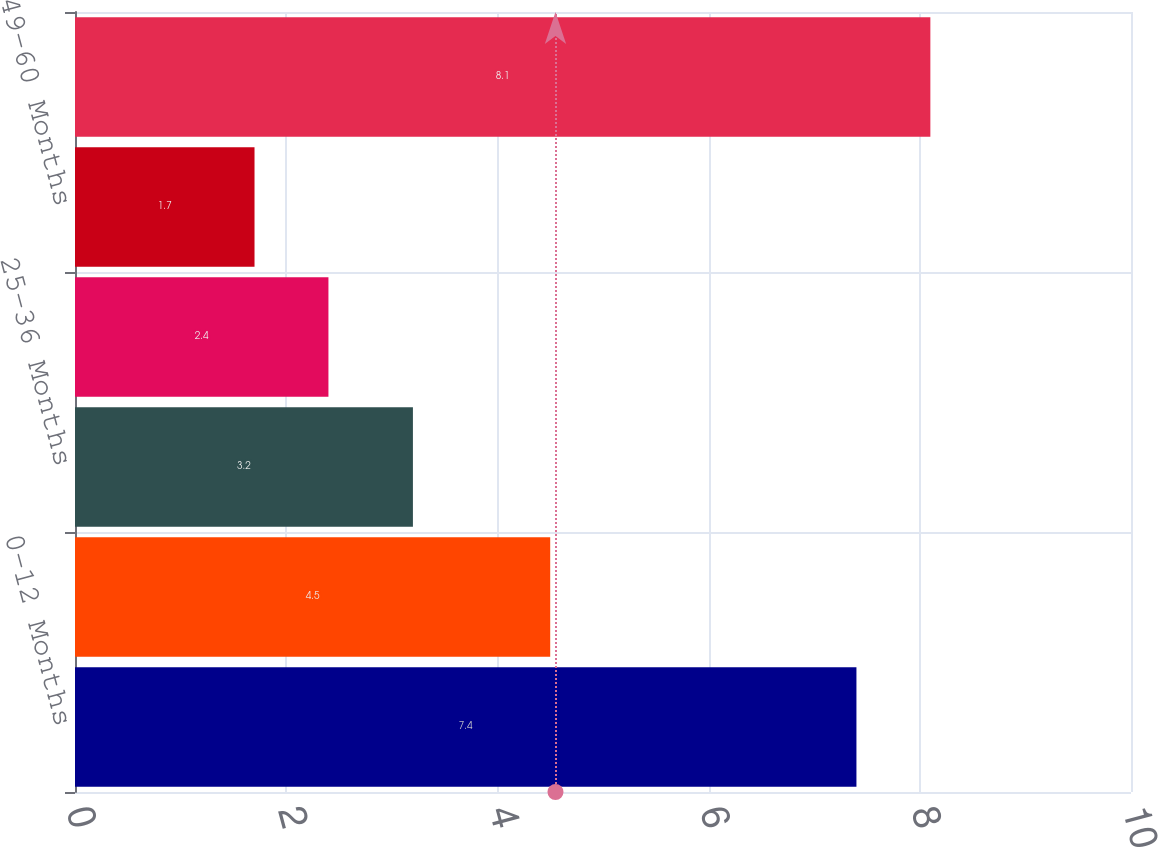Convert chart to OTSL. <chart><loc_0><loc_0><loc_500><loc_500><bar_chart><fcel>0-12 Months<fcel>13-24 Months<fcel>25-36 Months<fcel>37-48 Months<fcel>49-60 Months<fcel>Over60 Months<nl><fcel>7.4<fcel>4.5<fcel>3.2<fcel>2.4<fcel>1.7<fcel>8.1<nl></chart> 